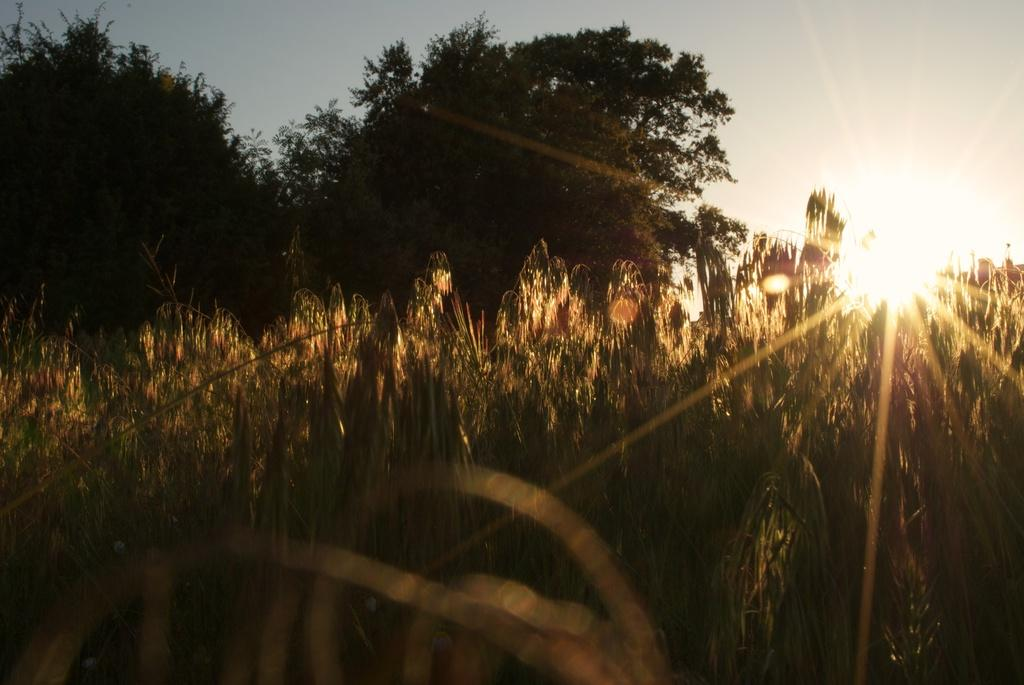What type of vegetation is present on the ground in the image? There are plants and trees on the ground in the image. What can be seen in the background of the image? The sky is visible in the background of the image. What celestial body is visible in the sky? The sun is visible in the sky. What type of cord is used to support the trees in the image? There is no cord visible in the image, and the trees are not supported by any visible means. 